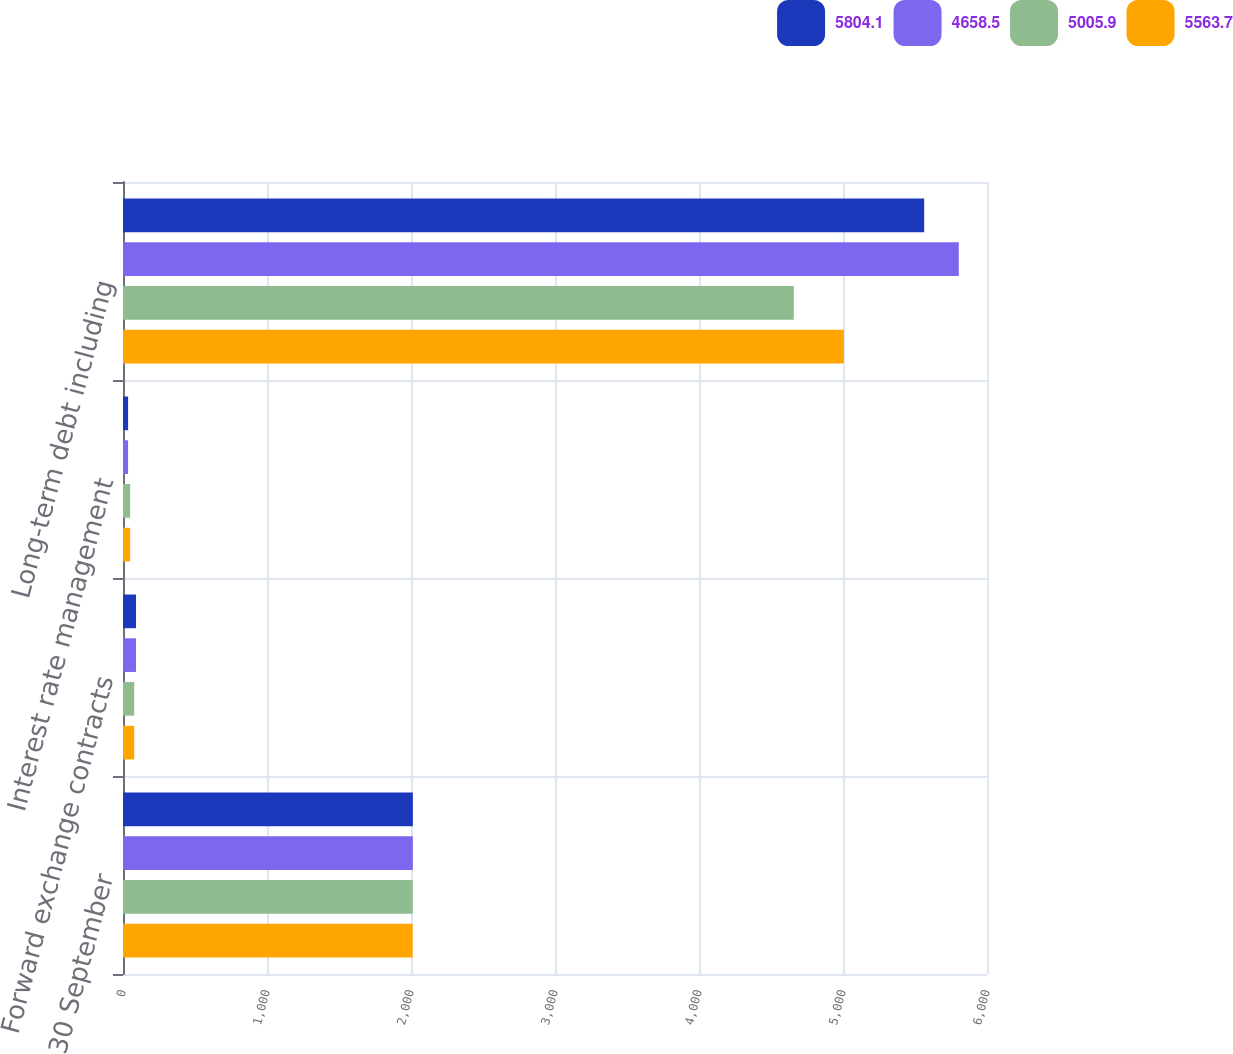Convert chart. <chart><loc_0><loc_0><loc_500><loc_500><stacked_bar_chart><ecel><fcel>30 September<fcel>Forward exchange contracts<fcel>Interest rate management<fcel>Long-term debt including<nl><fcel>5804.1<fcel>2013<fcel>90.5<fcel>35.4<fcel>5563.7<nl><fcel>4658.5<fcel>2013<fcel>90.5<fcel>35.4<fcel>5804.1<nl><fcel>5005.9<fcel>2012<fcel>77.9<fcel>49.7<fcel>4658.5<nl><fcel>5563.7<fcel>2012<fcel>77.9<fcel>49.7<fcel>5005.9<nl></chart> 